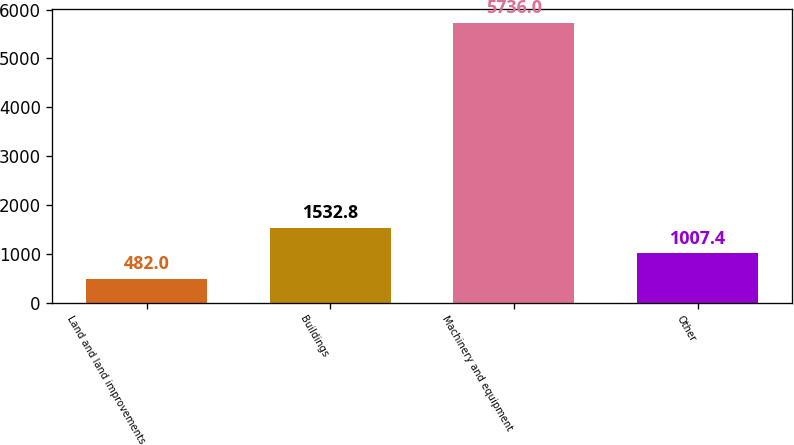Convert chart. <chart><loc_0><loc_0><loc_500><loc_500><bar_chart><fcel>Land and land improvements<fcel>Buildings<fcel>Machinery and equipment<fcel>Other<nl><fcel>482<fcel>1532.8<fcel>5736<fcel>1007.4<nl></chart> 